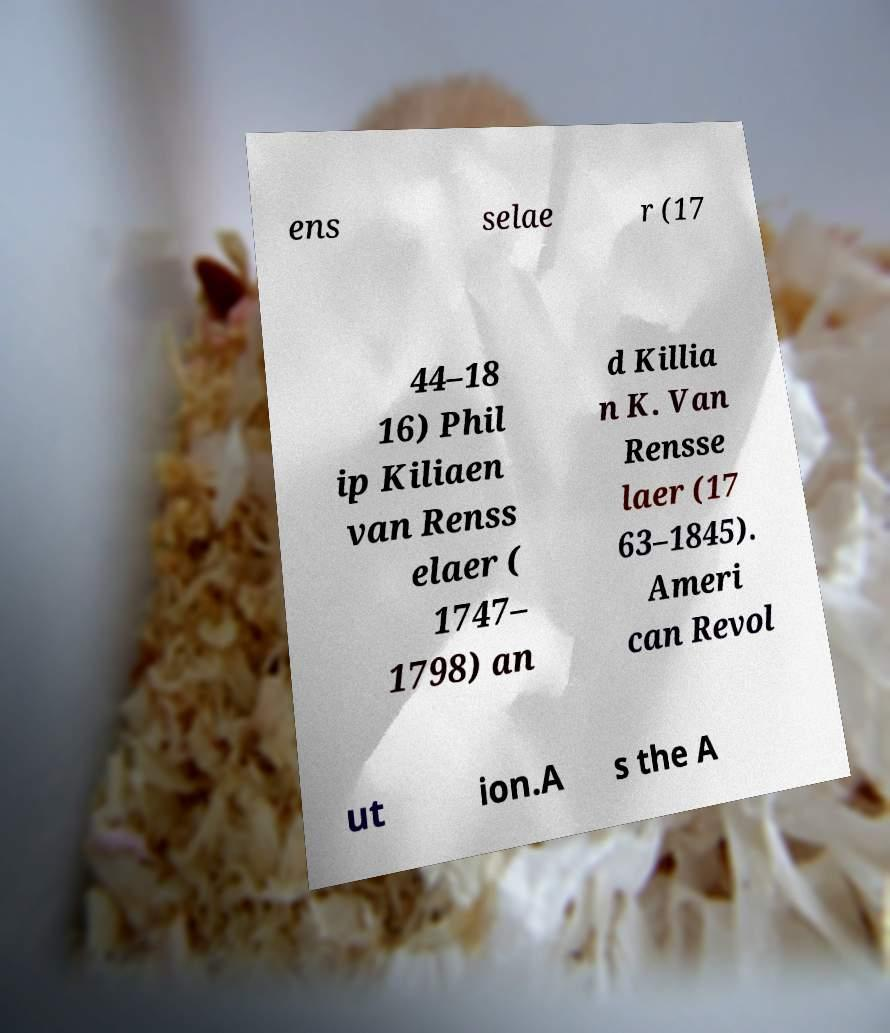Can you read and provide the text displayed in the image?This photo seems to have some interesting text. Can you extract and type it out for me? ens selae r (17 44–18 16) Phil ip Kiliaen van Renss elaer ( 1747– 1798) an d Killia n K. Van Rensse laer (17 63–1845). Ameri can Revol ut ion.A s the A 